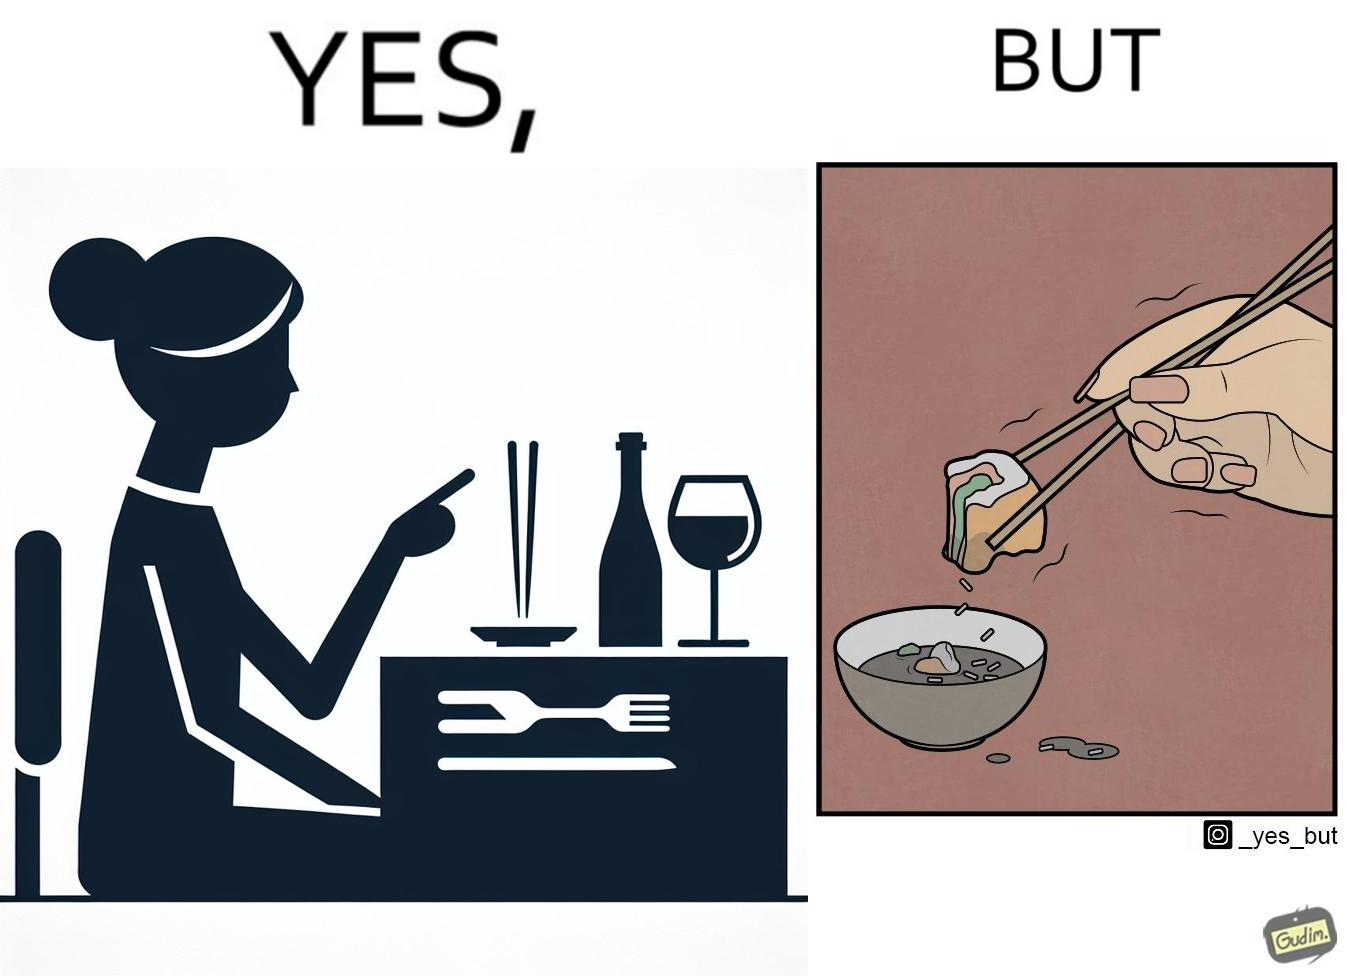Is this a satirical image? Yes, this image is satirical. 